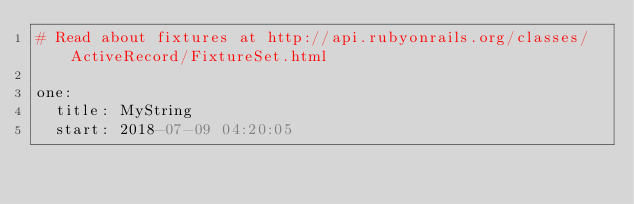Convert code to text. <code><loc_0><loc_0><loc_500><loc_500><_YAML_># Read about fixtures at http://api.rubyonrails.org/classes/ActiveRecord/FixtureSet.html

one:
  title: MyString
  start: 2018-07-09 04:20:05</code> 